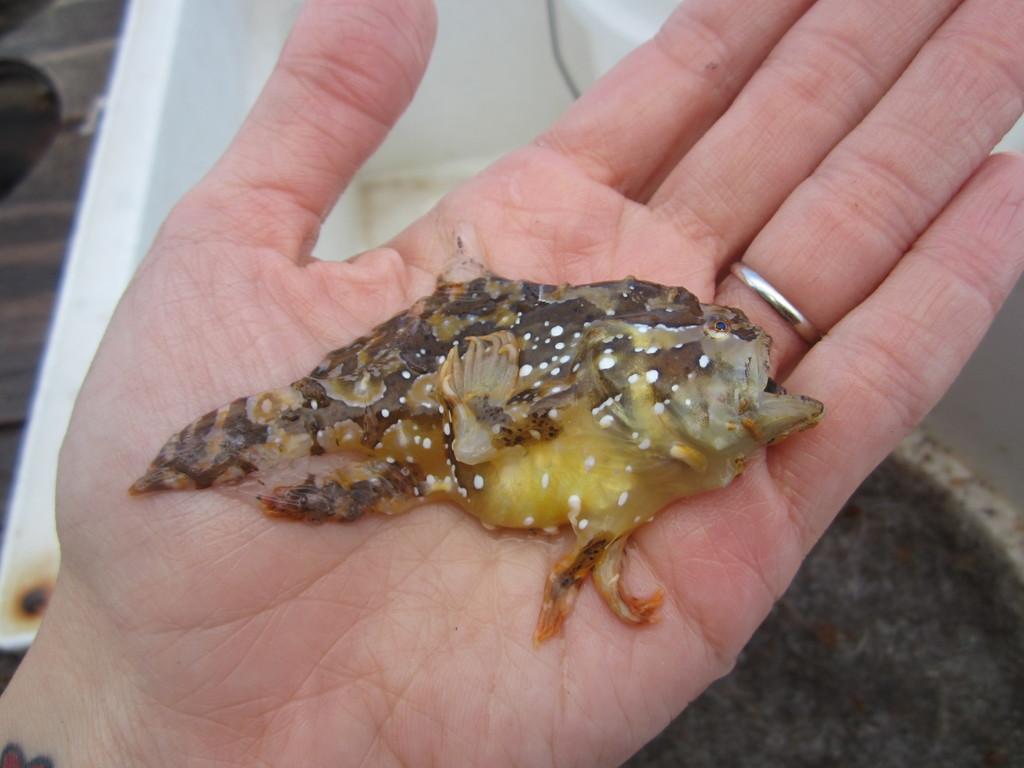Could you give a brief overview of what you see in this image? In this image we can see something in the person's hand. In the background, we can see few things. 